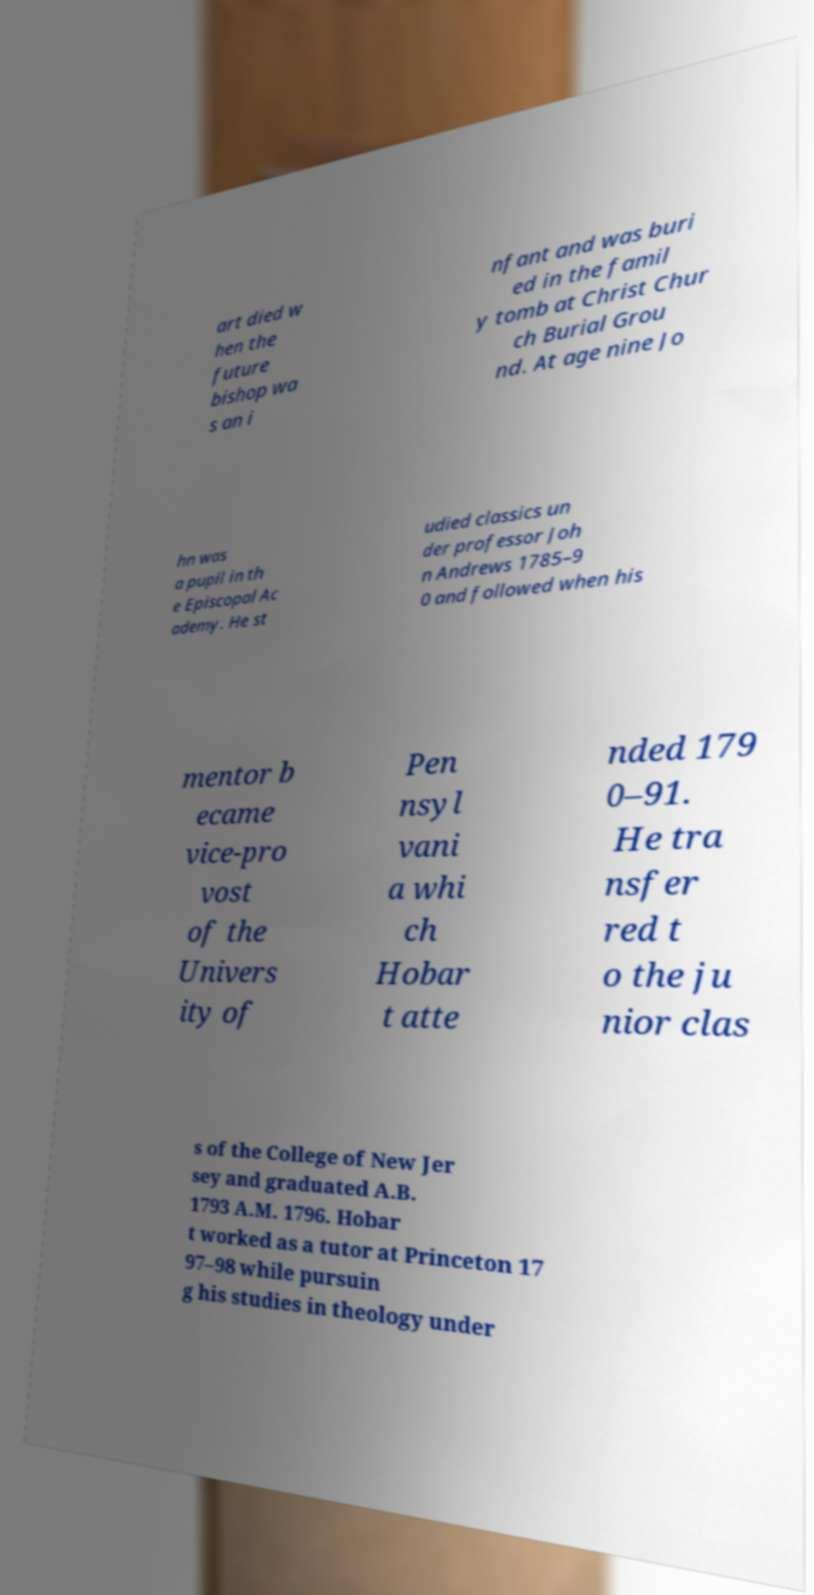I need the written content from this picture converted into text. Can you do that? art died w hen the future bishop wa s an i nfant and was buri ed in the famil y tomb at Christ Chur ch Burial Grou nd. At age nine Jo hn was a pupil in th e Episcopal Ac ademy. He st udied classics un der professor Joh n Andrews 1785–9 0 and followed when his mentor b ecame vice-pro vost of the Univers ity of Pen nsyl vani a whi ch Hobar t atte nded 179 0–91. He tra nsfer red t o the ju nior clas s of the College of New Jer sey and graduated A.B. 1793 A.M. 1796. Hobar t worked as a tutor at Princeton 17 97–98 while pursuin g his studies in theology under 